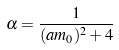Convert formula to latex. <formula><loc_0><loc_0><loc_500><loc_500>\alpha = \frac { 1 } { ( a m _ { 0 } ) ^ { 2 } + 4 }</formula> 